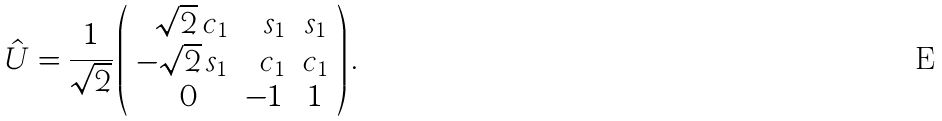Convert formula to latex. <formula><loc_0><loc_0><loc_500><loc_500>\hat { U } = \frac { 1 } { \sqrt { 2 } } \left ( \begin{array} { r r c } \sqrt { 2 } \, c _ { 1 } & s _ { 1 } & s _ { 1 } \\ - \sqrt { 2 } \, s _ { 1 } & c _ { 1 } & c _ { 1 } \\ 0 \quad & - 1 \, & 1 \end{array} \right ) .</formula> 